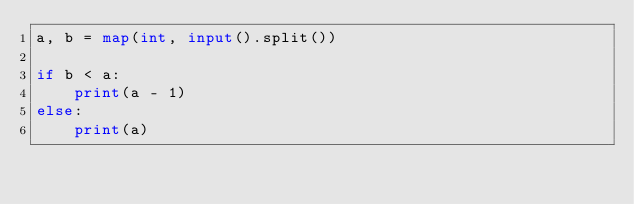<code> <loc_0><loc_0><loc_500><loc_500><_Python_>a, b = map(int, input().split())

if b < a:
    print(a - 1)
else:
    print(a)</code> 